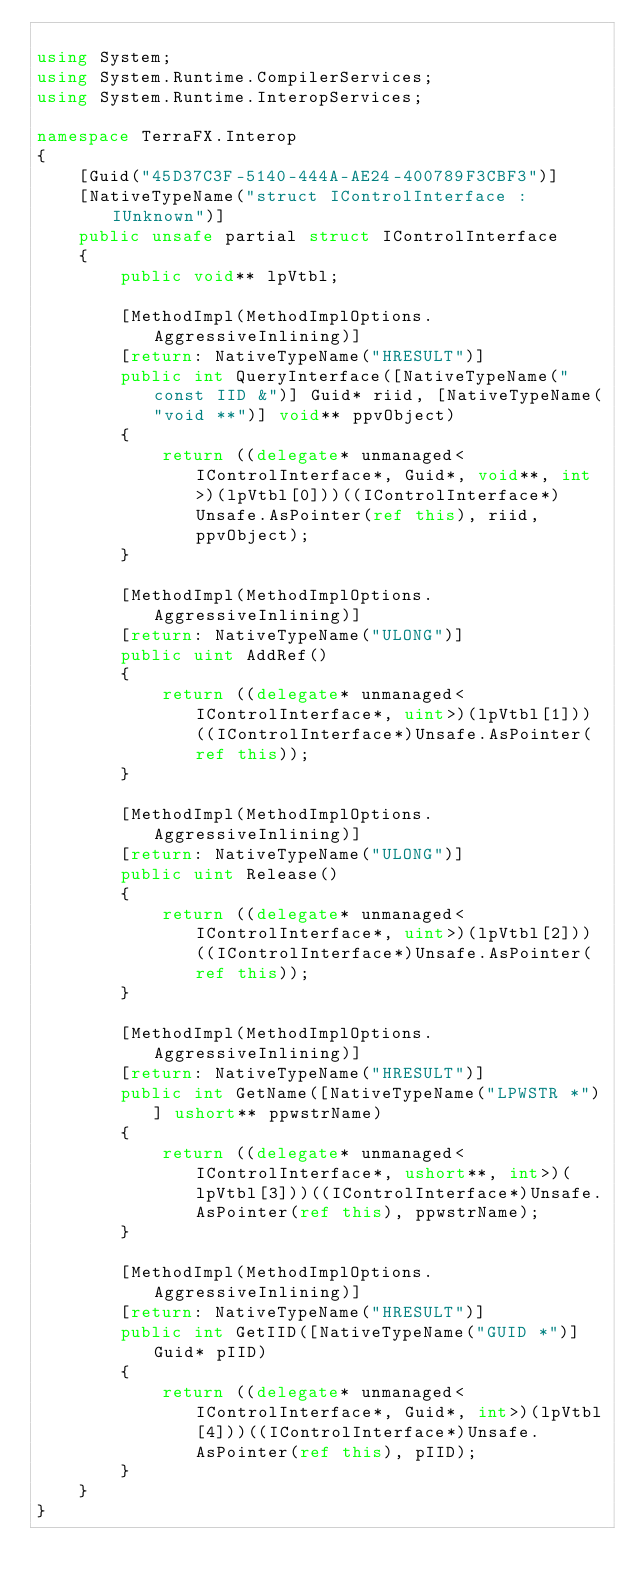<code> <loc_0><loc_0><loc_500><loc_500><_C#_>
using System;
using System.Runtime.CompilerServices;
using System.Runtime.InteropServices;

namespace TerraFX.Interop
{
    [Guid("45D37C3F-5140-444A-AE24-400789F3CBF3")]
    [NativeTypeName("struct IControlInterface : IUnknown")]
    public unsafe partial struct IControlInterface
    {
        public void** lpVtbl;

        [MethodImpl(MethodImplOptions.AggressiveInlining)]
        [return: NativeTypeName("HRESULT")]
        public int QueryInterface([NativeTypeName("const IID &")] Guid* riid, [NativeTypeName("void **")] void** ppvObject)
        {
            return ((delegate* unmanaged<IControlInterface*, Guid*, void**, int>)(lpVtbl[0]))((IControlInterface*)Unsafe.AsPointer(ref this), riid, ppvObject);
        }

        [MethodImpl(MethodImplOptions.AggressiveInlining)]
        [return: NativeTypeName("ULONG")]
        public uint AddRef()
        {
            return ((delegate* unmanaged<IControlInterface*, uint>)(lpVtbl[1]))((IControlInterface*)Unsafe.AsPointer(ref this));
        }

        [MethodImpl(MethodImplOptions.AggressiveInlining)]
        [return: NativeTypeName("ULONG")]
        public uint Release()
        {
            return ((delegate* unmanaged<IControlInterface*, uint>)(lpVtbl[2]))((IControlInterface*)Unsafe.AsPointer(ref this));
        }

        [MethodImpl(MethodImplOptions.AggressiveInlining)]
        [return: NativeTypeName("HRESULT")]
        public int GetName([NativeTypeName("LPWSTR *")] ushort** ppwstrName)
        {
            return ((delegate* unmanaged<IControlInterface*, ushort**, int>)(lpVtbl[3]))((IControlInterface*)Unsafe.AsPointer(ref this), ppwstrName);
        }

        [MethodImpl(MethodImplOptions.AggressiveInlining)]
        [return: NativeTypeName("HRESULT")]
        public int GetIID([NativeTypeName("GUID *")] Guid* pIID)
        {
            return ((delegate* unmanaged<IControlInterface*, Guid*, int>)(lpVtbl[4]))((IControlInterface*)Unsafe.AsPointer(ref this), pIID);
        }
    }
}
</code> 